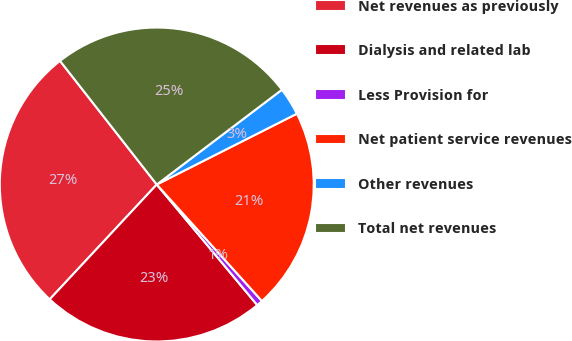Convert chart to OTSL. <chart><loc_0><loc_0><loc_500><loc_500><pie_chart><fcel>Net revenues as previously<fcel>Dialysis and related lab<fcel>Less Provision for<fcel>Net patient service revenues<fcel>Other revenues<fcel>Total net revenues<nl><fcel>27.49%<fcel>23.0%<fcel>0.63%<fcel>20.76%<fcel>2.87%<fcel>25.25%<nl></chart> 